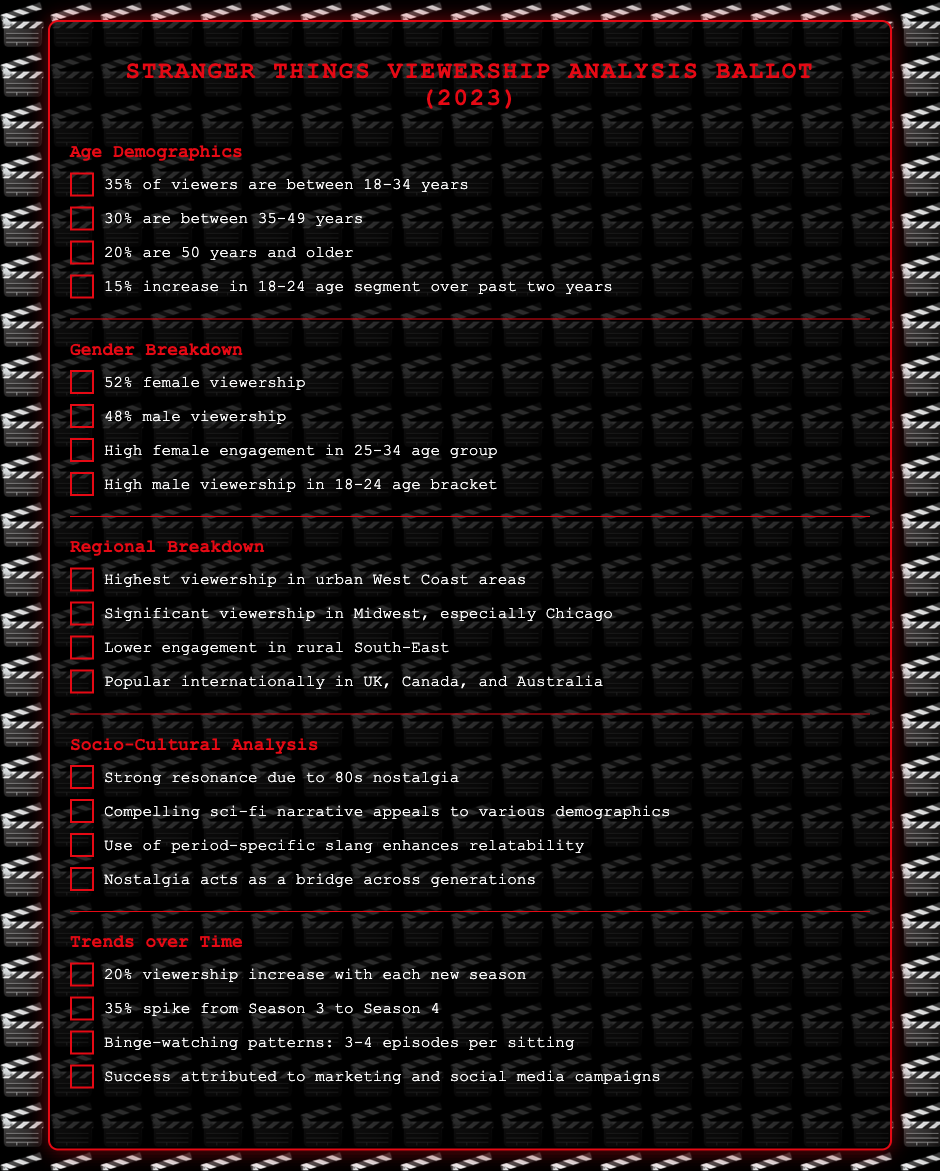What percentage of viewers are between 18-34 years? The document states that 35% of viewers are between 18-34 years.
Answer: 35% What is the highest demographic engagement age group for female viewers? The document indicates that there is high female engagement in the 25-34 age group.
Answer: 25-34 Which region has the highest viewership? The document mentions that the highest viewership is in urban West Coast areas.
Answer: Urban West Coast areas What was the percentage increase for the 18-24 age segment over the past two years? The document states that there is a 15% increase in the 18-24 age segment over the past two years.
Answer: 15% What is the percentage of male viewership? The document specifies that 48% of the viewership is male.
Answer: 48% What trend is observed regarding viewership with each new season? The document mentions that there is a 20% viewership increase with each new season.
Answer: 20% What is the spike in viewership from Season 3 to Season 4? The document highlights a 35% spike in viewership from Season 3 to Season 4.
Answer: 35% What factor contributes to the show's success according to the document? The document attributes the success to marketing and social media campaigns.
Answer: Marketing and social media campaigns What cultural element helps in appealing to different demographics? The document states that a compelling sci-fi narrative appeals to various demographics.
Answer: Compelling sci-fi narrative 